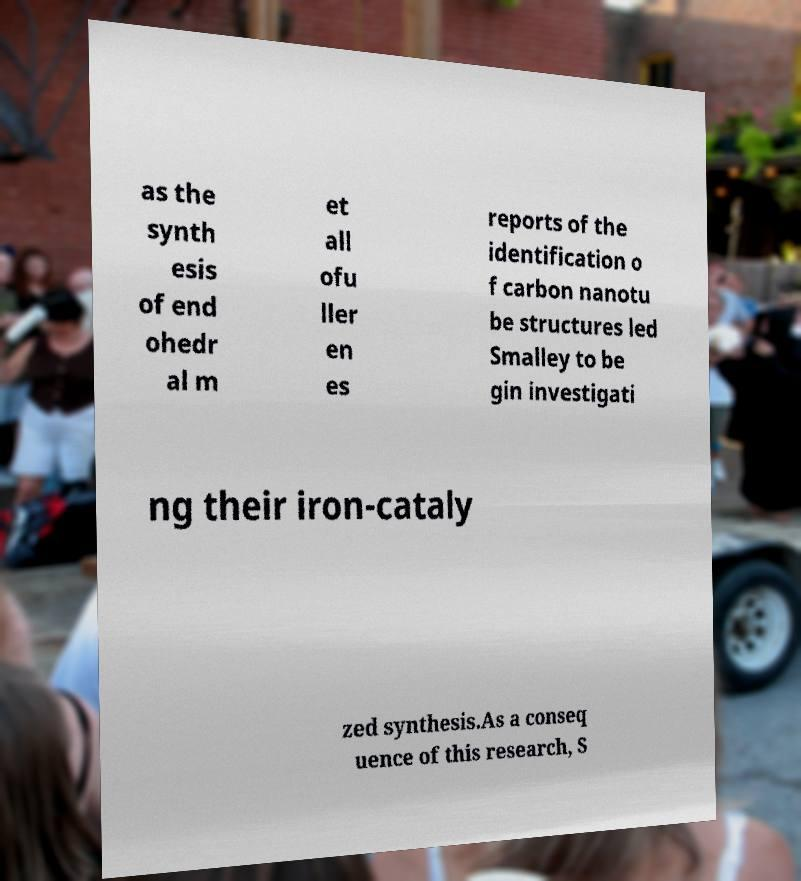Please identify and transcribe the text found in this image. as the synth esis of end ohedr al m et all ofu ller en es reports of the identification o f carbon nanotu be structures led Smalley to be gin investigati ng their iron-cataly zed synthesis.As a conseq uence of this research, S 